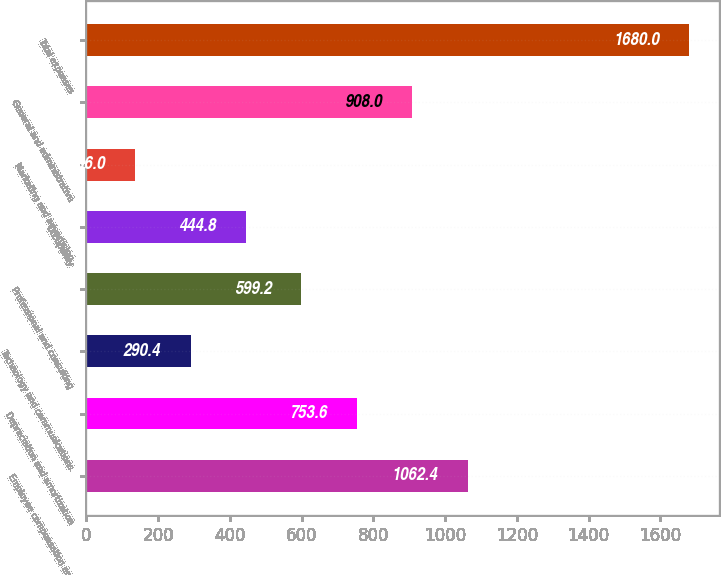Convert chart. <chart><loc_0><loc_0><loc_500><loc_500><bar_chart><fcel>Employee compensation and<fcel>Depreciation and amortization<fcel>Technology and communications<fcel>Professional and consulting<fcel>Occupancy<fcel>Marketing and advertising<fcel>General and administrative<fcel>Total expenses<nl><fcel>1062.4<fcel>753.6<fcel>290.4<fcel>599.2<fcel>444.8<fcel>136<fcel>908<fcel>1680<nl></chart> 